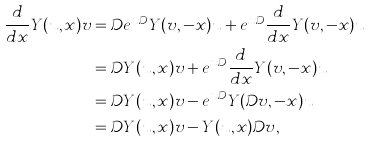Convert formula to latex. <formula><loc_0><loc_0><loc_500><loc_500>\frac { d } { d x } Y ( u , x ) v & = \mathcal { D } e ^ { x \mathcal { D } } Y ( v , - x ) u + e ^ { x \mathcal { D } } \frac { d } { d x } Y ( v , - x ) u \\ & = \mathcal { D } Y ( u , x ) v + e ^ { x \mathcal { D } } \frac { d } { d x } Y ( v , - x ) u \\ & = \mathcal { D } Y ( u , x ) v - e ^ { x \mathcal { D } } Y ( \mathcal { D } v , - x ) u \\ & = \mathcal { D } Y ( u , x ) v - Y ( u , x ) \mathcal { D } v ,</formula> 